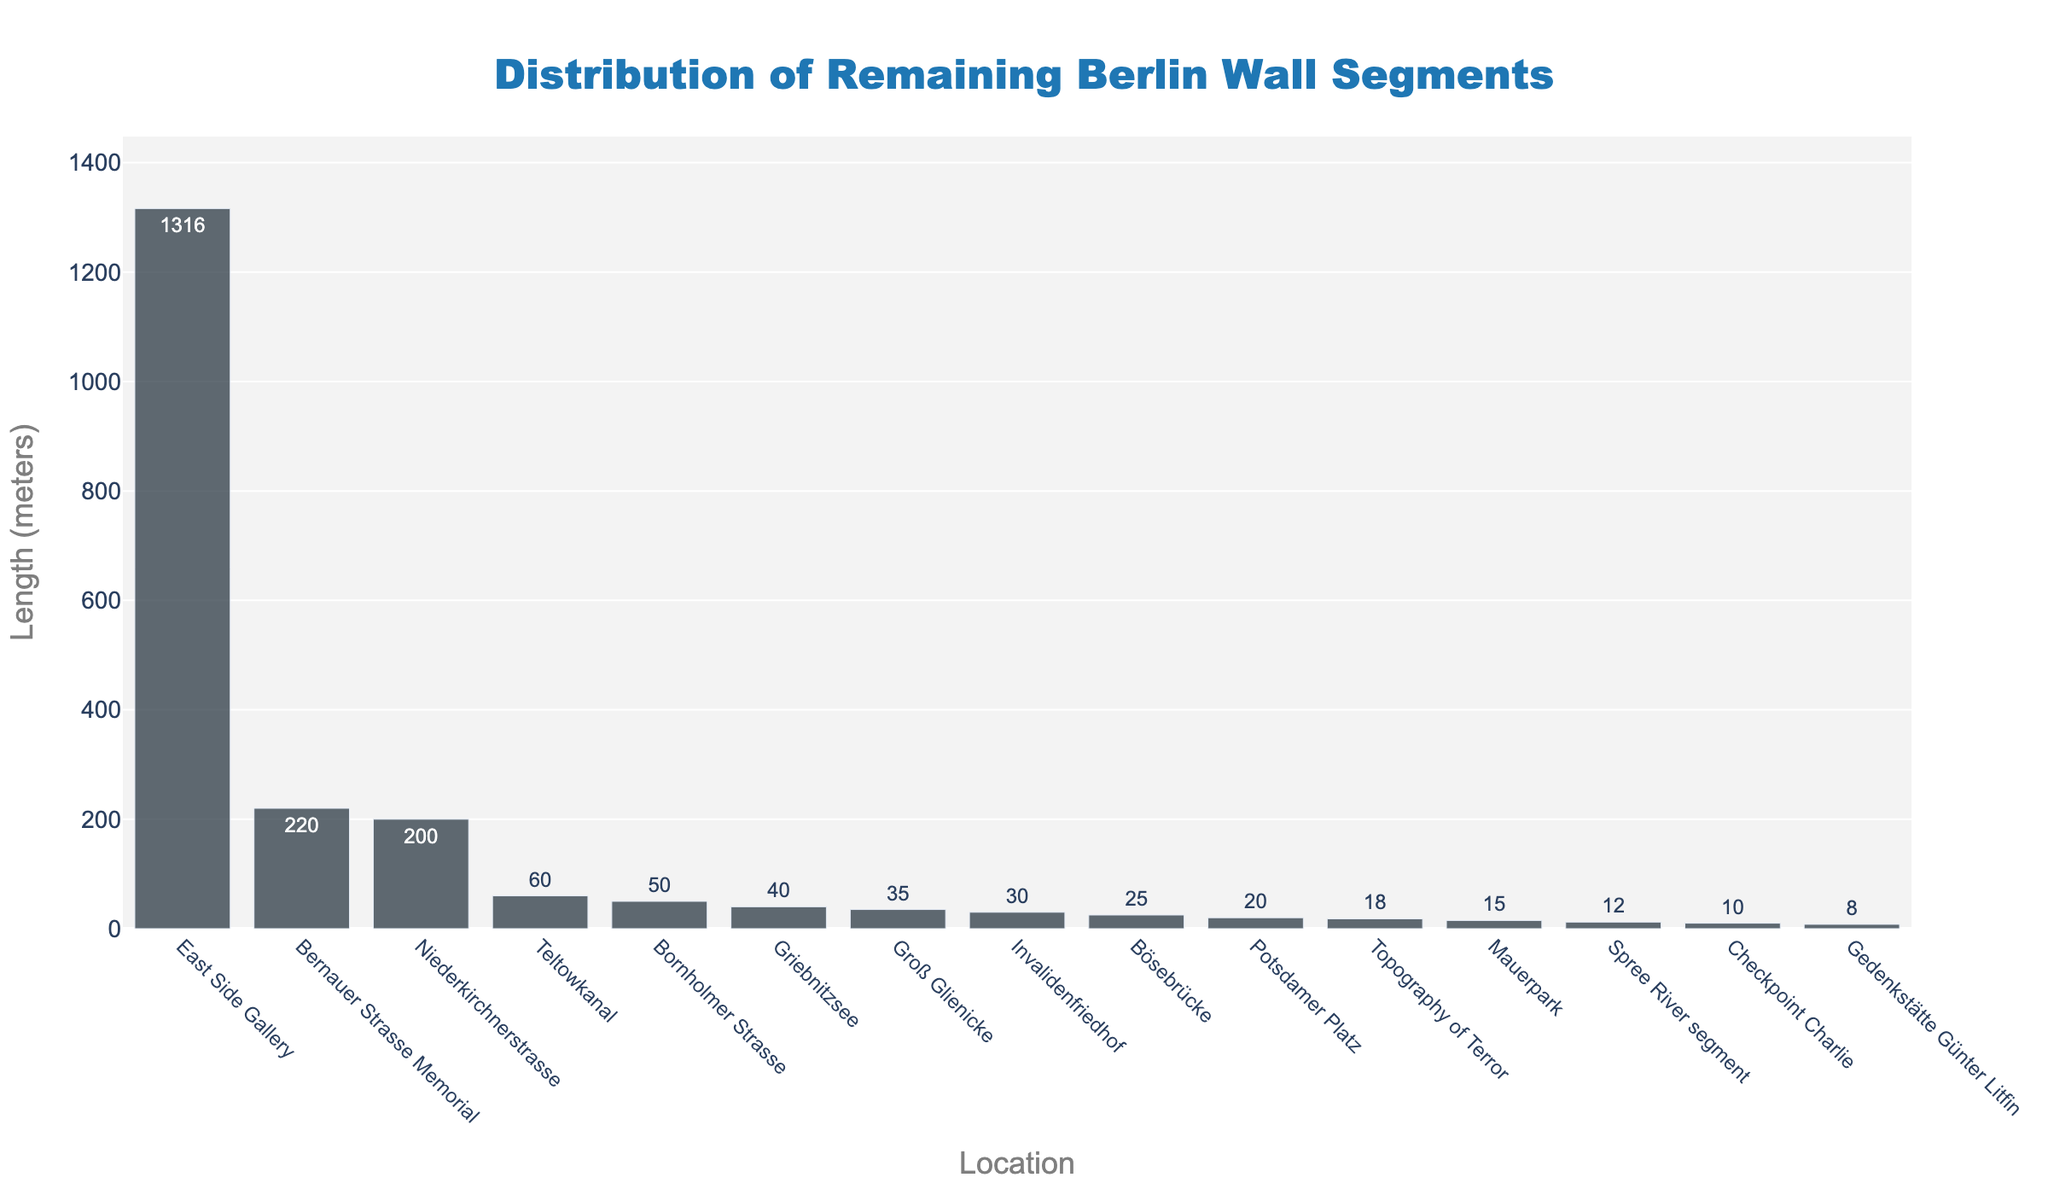Which location has the longest remaining segment of the Berlin Wall? The longest segment can be identified by looking for the tallest bar in the chart.
Answer: East Side Gallery Which location has a remaining segment that is shorter than 20 meters? Look for the bars that are shorter than the 20-meter mark on the y-axis.
Answer: Gedenkstätte Günter Litfin and Checkpoint Charlie What is the total length of the remaining segments at East Side Gallery and Bernauer Strasse Memorial combined? Add the lengths of the segments at East Side Gallery (1316 meters) and Bernauer Strasse Memorial (220 meters). 1316 + 220 = 1536 meters
Answer: 1536 meters How much longer is the segment at Niederkirchnerstrasse compared to the segment at Bornholmer Strasse? Subtract the length of the segment at Bornholmer Strasse (50 meters) from the segment at Niederkirchnerstrasse (200 meters). 200 - 50 = 150 meters
Answer: 150 meters Which locations have segments between 10 meters and 30 meters in length? Identify the bars that fall within the 10 to 30 meters range on the y-axis.
Answer: Potsdamer Platz, Invalidenfriedhof, Bösebrücke, Checkpoint Charlie, Gedenkstätte Günter Litfin, Spree River segment 